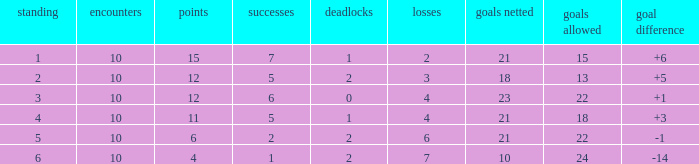Can you tell me the sum of Goals against that has the Goals for larger than 10, and the Position of 3, and the Wins smaller than 6? None. 